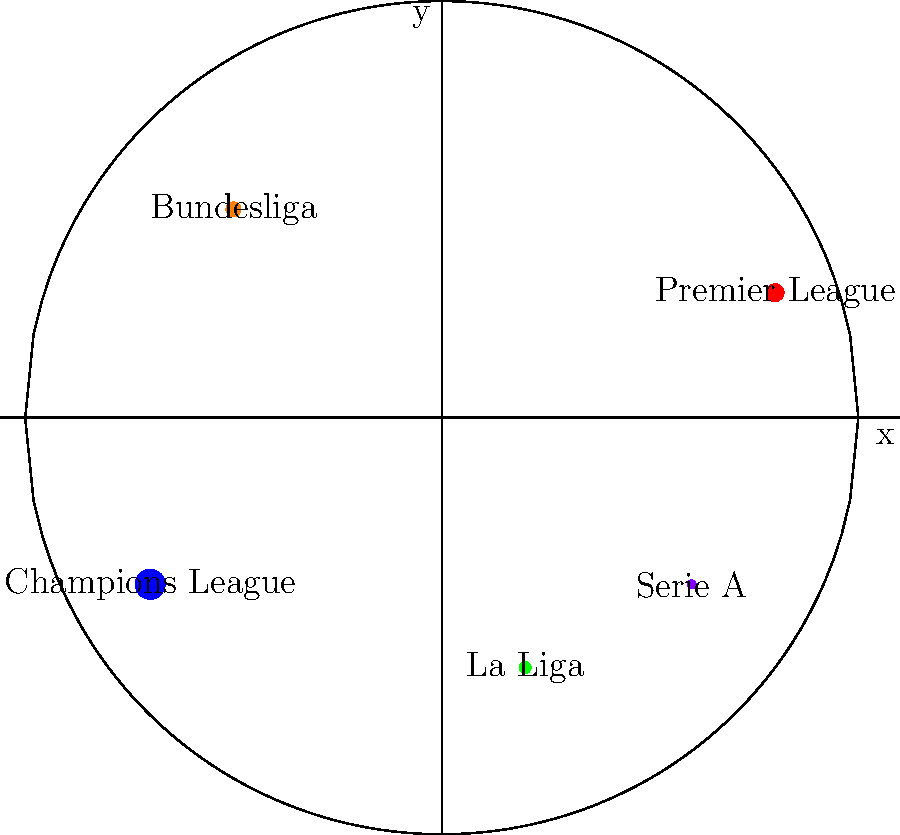Based on the bubble chart representing sponsorship deal values for different football competitions, which league has the highest sponsorship value, and approximately how much larger is it compared to the league with the smallest bubble? To answer this question, we need to analyze the bubble chart:

1. Identify the largest bubble: The blue bubble representing the Champions League is the largest.
2. Identify the smallest bubble: The purple bubble representing Serie A is the smallest.
3. Compare the sizes: The Champions League bubble is approximately 3-4 times larger than the Serie A bubble.
4. Interpret the size difference: In bubble charts, the area of the bubble typically represents the value. A 3-4 times larger area suggests a significantly higher sponsorship value.
5. Estimate the difference: Without exact numbers, we can estimate that the Champions League sponsorship value is about 3-4 times higher than Serie A's.

Therefore, the Champions League has the highest sponsorship value, and it's approximately 3-4 times larger than Serie A, which has the smallest bubble in the chart.
Answer: Champions League; approximately 3-4 times larger 